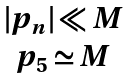<formula> <loc_0><loc_0><loc_500><loc_500>\begin{array} { c } | p _ { n } | \ll M \\ p _ { 5 } \simeq M \\ \end{array}</formula> 